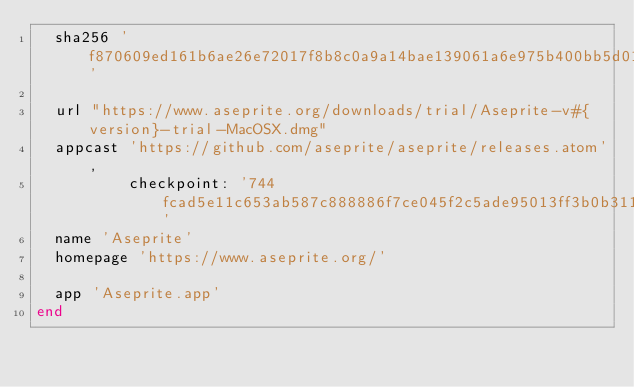Convert code to text. <code><loc_0><loc_0><loc_500><loc_500><_Ruby_>  sha256 'f870609ed161b6ae26e72017f8b8c0a9a14bae139061a6e975b400bb5d01d00c'

  url "https://www.aseprite.org/downloads/trial/Aseprite-v#{version}-trial-MacOSX.dmg"
  appcast 'https://github.com/aseprite/aseprite/releases.atom',
          checkpoint: '744fcad5e11c653ab587c888886f7ce045f2c5ade95013ff3b0b31109c58211e'
  name 'Aseprite'
  homepage 'https://www.aseprite.org/'

  app 'Aseprite.app'
end
</code> 